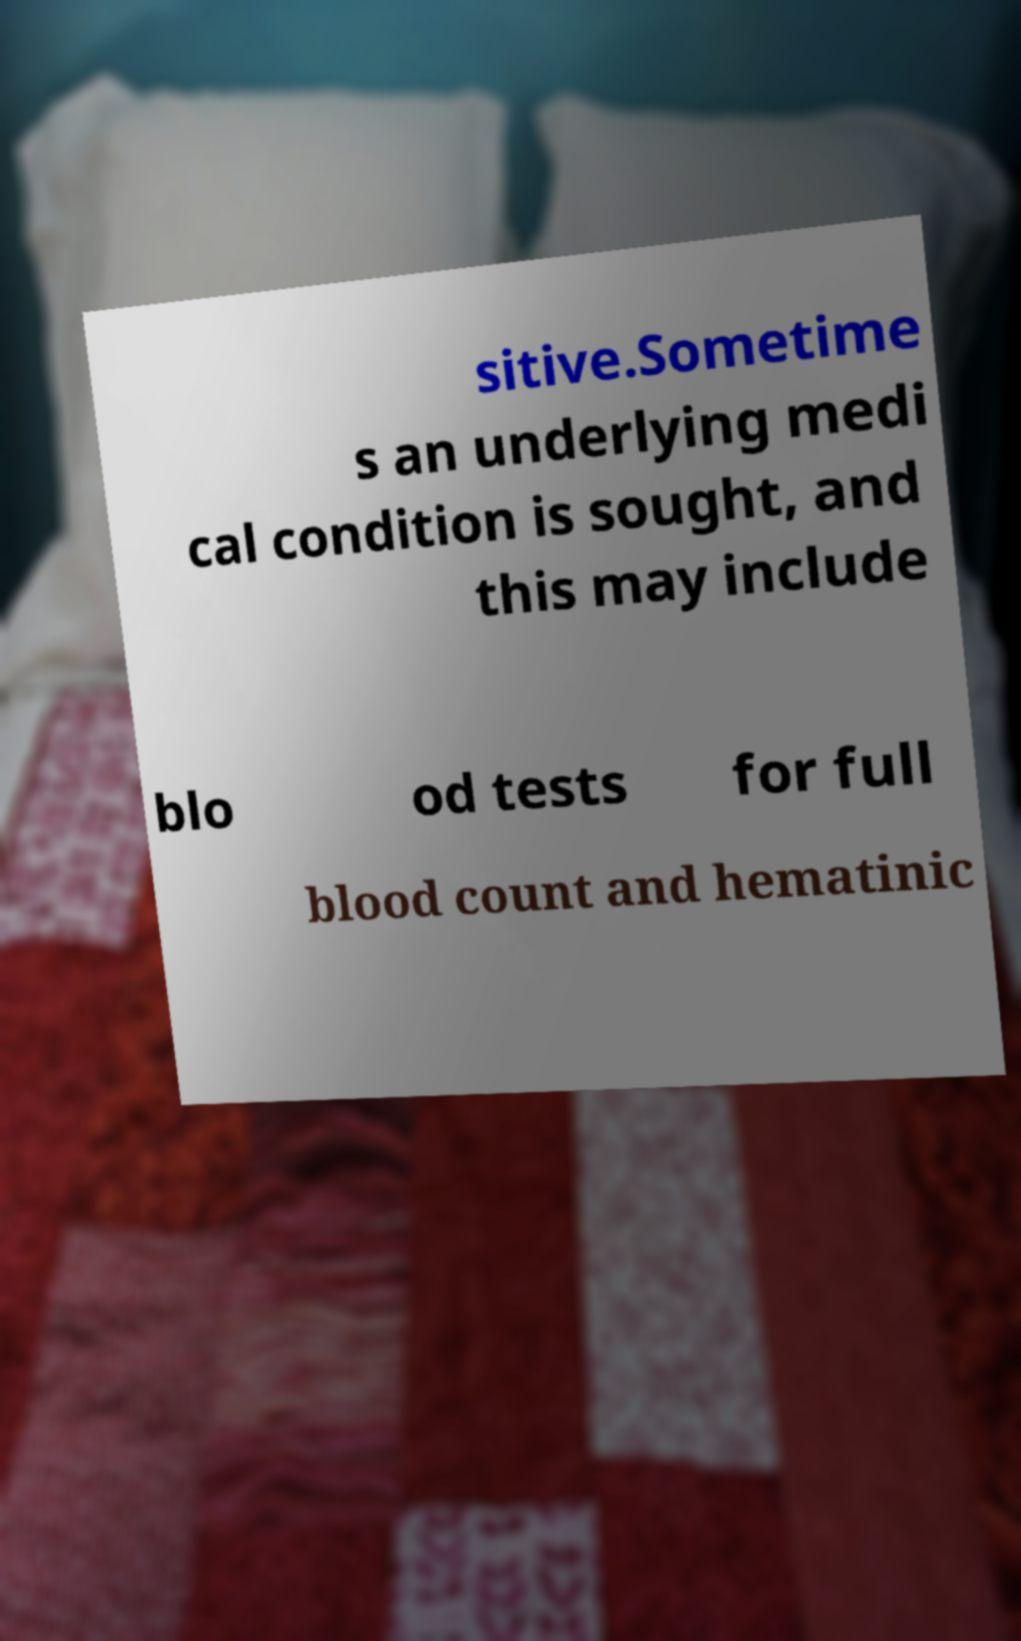Could you assist in decoding the text presented in this image and type it out clearly? sitive.Sometime s an underlying medi cal condition is sought, and this may include blo od tests for full blood count and hematinic 